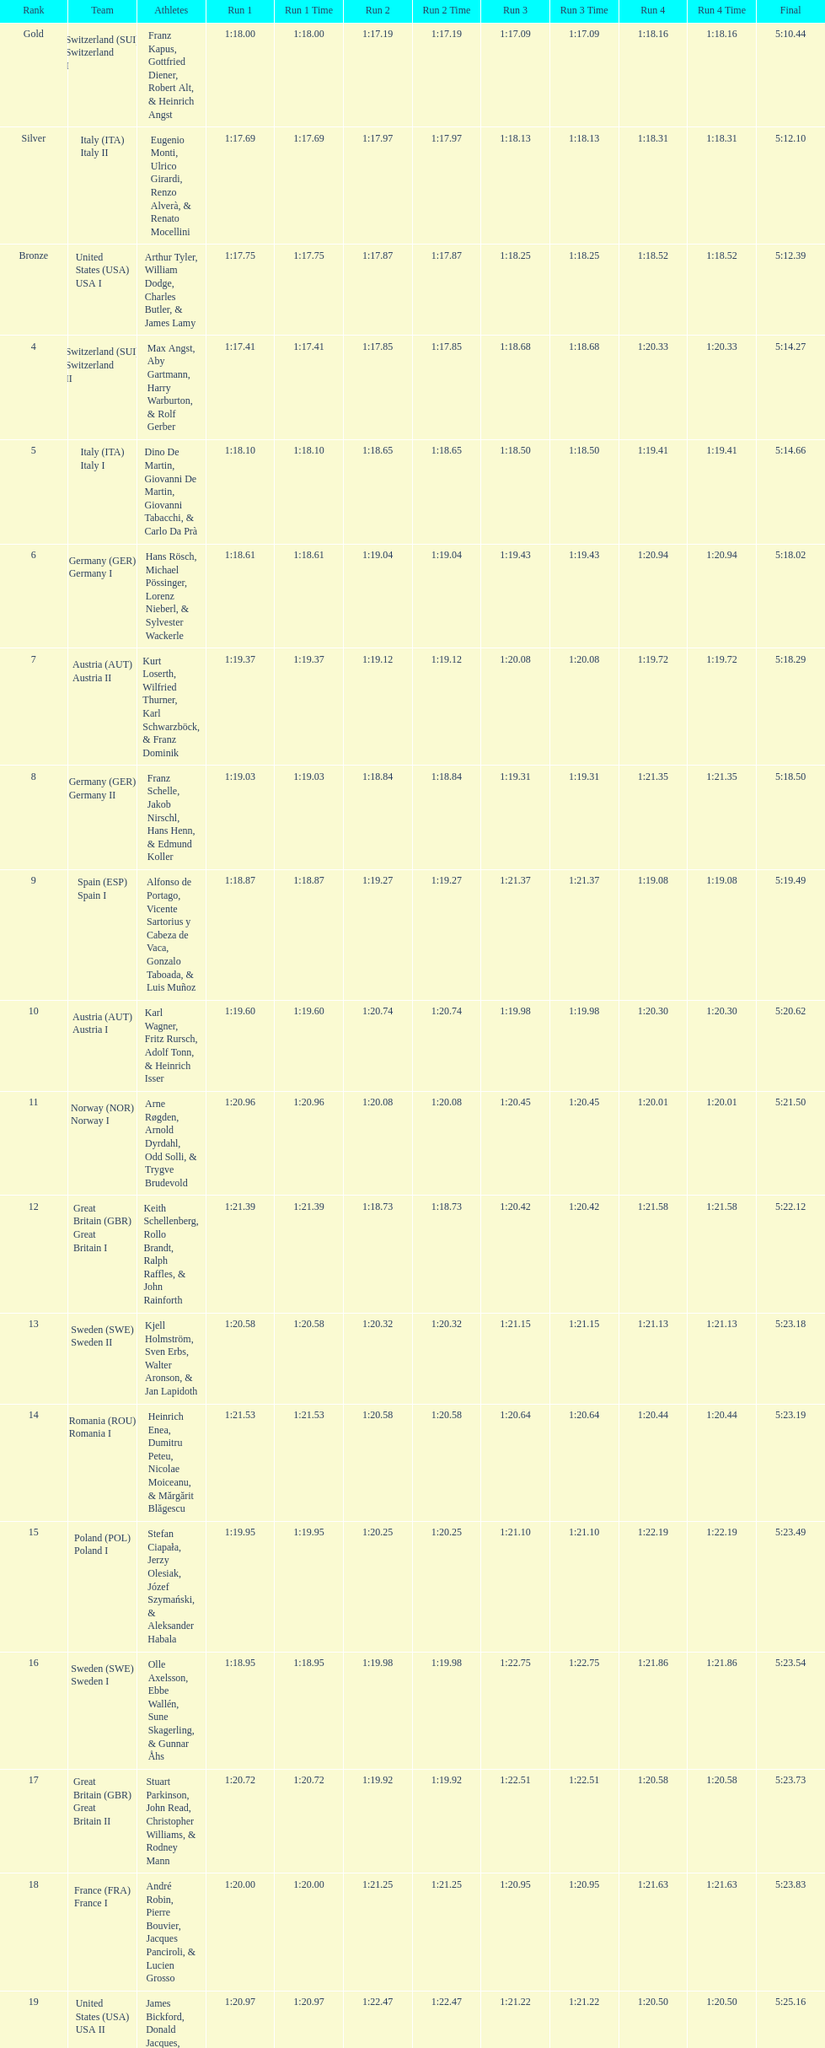Which team won the most runs? Switzerland. Would you be able to parse every entry in this table? {'header': ['Rank', 'Team', 'Athletes', 'Run 1', 'Run 1 Time', 'Run 2', 'Run 2 Time', 'Run 3', 'Run 3 Time', 'Run 4', 'Run 4 Time', 'Final'], 'rows': [['Gold', 'Switzerland\xa0(SUI) Switzerland I', 'Franz Kapus, Gottfried Diener, Robert Alt, & Heinrich Angst', '1:18.00', '1:18.00', '1:17.19', '1:17.19', '1:17.09', '1:17.09', '1:18.16', '1:18.16', '5:10.44'], ['Silver', 'Italy\xa0(ITA) Italy II', 'Eugenio Monti, Ulrico Girardi, Renzo Alverà, & Renato Mocellini', '1:17.69', '1:17.69', '1:17.97', '1:17.97', '1:18.13', '1:18.13', '1:18.31', '1:18.31', '5:12.10'], ['Bronze', 'United States\xa0(USA) USA I', 'Arthur Tyler, William Dodge, Charles Butler, & James Lamy', '1:17.75', '1:17.75', '1:17.87', '1:17.87', '1:18.25', '1:18.25', '1:18.52', '1:18.52', '5:12.39'], ['4', 'Switzerland\xa0(SUI) Switzerland II', 'Max Angst, Aby Gartmann, Harry Warburton, & Rolf Gerber', '1:17.41', '1:17.41', '1:17.85', '1:17.85', '1:18.68', '1:18.68', '1:20.33', '1:20.33', '5:14.27'], ['5', 'Italy\xa0(ITA) Italy I', 'Dino De Martin, Giovanni De Martin, Giovanni Tabacchi, & Carlo Da Prà', '1:18.10', '1:18.10', '1:18.65', '1:18.65', '1:18.50', '1:18.50', '1:19.41', '1:19.41', '5:14.66'], ['6', 'Germany\xa0(GER) Germany I', 'Hans Rösch, Michael Pössinger, Lorenz Nieberl, & Sylvester Wackerle', '1:18.61', '1:18.61', '1:19.04', '1:19.04', '1:19.43', '1:19.43', '1:20.94', '1:20.94', '5:18.02'], ['7', 'Austria\xa0(AUT) Austria II', 'Kurt Loserth, Wilfried Thurner, Karl Schwarzböck, & Franz Dominik', '1:19.37', '1:19.37', '1:19.12', '1:19.12', '1:20.08', '1:20.08', '1:19.72', '1:19.72', '5:18.29'], ['8', 'Germany\xa0(GER) Germany II', 'Franz Schelle, Jakob Nirschl, Hans Henn, & Edmund Koller', '1:19.03', '1:19.03', '1:18.84', '1:18.84', '1:19.31', '1:19.31', '1:21.35', '1:21.35', '5:18.50'], ['9', 'Spain\xa0(ESP) Spain I', 'Alfonso de Portago, Vicente Sartorius y Cabeza de Vaca, Gonzalo Taboada, & Luis Muñoz', '1:18.87', '1:18.87', '1:19.27', '1:19.27', '1:21.37', '1:21.37', '1:19.08', '1:19.08', '5:19.49'], ['10', 'Austria\xa0(AUT) Austria I', 'Karl Wagner, Fritz Rursch, Adolf Tonn, & Heinrich Isser', '1:19.60', '1:19.60', '1:20.74', '1:20.74', '1:19.98', '1:19.98', '1:20.30', '1:20.30', '5:20.62'], ['11', 'Norway\xa0(NOR) Norway I', 'Arne Røgden, Arnold Dyrdahl, Odd Solli, & Trygve Brudevold', '1:20.96', '1:20.96', '1:20.08', '1:20.08', '1:20.45', '1:20.45', '1:20.01', '1:20.01', '5:21.50'], ['12', 'Great Britain\xa0(GBR) Great Britain I', 'Keith Schellenberg, Rollo Brandt, Ralph Raffles, & John Rainforth', '1:21.39', '1:21.39', '1:18.73', '1:18.73', '1:20.42', '1:20.42', '1:21.58', '1:21.58', '5:22.12'], ['13', 'Sweden\xa0(SWE) Sweden II', 'Kjell Holmström, Sven Erbs, Walter Aronson, & Jan Lapidoth', '1:20.58', '1:20.58', '1:20.32', '1:20.32', '1:21.15', '1:21.15', '1:21.13', '1:21.13', '5:23.18'], ['14', 'Romania\xa0(ROU) Romania I', 'Heinrich Enea, Dumitru Peteu, Nicolae Moiceanu, & Mărgărit Blăgescu', '1:21.53', '1:21.53', '1:20.58', '1:20.58', '1:20.64', '1:20.64', '1:20.44', '1:20.44', '5:23.19'], ['15', 'Poland\xa0(POL) Poland I', 'Stefan Ciapała, Jerzy Olesiak, Józef Szymański, & Aleksander Habala', '1:19.95', '1:19.95', '1:20.25', '1:20.25', '1:21.10', '1:21.10', '1:22.19', '1:22.19', '5:23.49'], ['16', 'Sweden\xa0(SWE) Sweden I', 'Olle Axelsson, Ebbe Wallén, Sune Skagerling, & Gunnar Åhs', '1:18.95', '1:18.95', '1:19.98', '1:19.98', '1:22.75', '1:22.75', '1:21.86', '1:21.86', '5:23.54'], ['17', 'Great Britain\xa0(GBR) Great Britain II', 'Stuart Parkinson, John Read, Christopher Williams, & Rodney Mann', '1:20.72', '1:20.72', '1:19.92', '1:19.92', '1:22.51', '1:22.51', '1:20.58', '1:20.58', '5:23.73'], ['18', 'France\xa0(FRA) France I', 'André Robin, Pierre Bouvier, Jacques Panciroli, & Lucien Grosso', '1:20.00', '1:20.00', '1:21.25', '1:21.25', '1:20.95', '1:20.95', '1:21.63', '1:21.63', '5:23.83'], ['19', 'United States\xa0(USA) USA II', 'James Bickford, Donald Jacques, Lawrence McKillip, & Hubert Miller', '1:20.97', '1:20.97', '1:22.47', '1:22.47', '1:21.22', '1:21.22', '1:20.50', '1:20.50', '5:25.16'], ['20', 'Romania\xa0(ROU) Romania II', 'Constantin Dragomir, Vasile Panait, Ion Staicu, & Gheorghe Moldoveanu', '1:21.21', '1:21.21', '1:21.22', '1:21.22', '1:22.37', '1:22.37', '1:23.03', '1:23.03', '5:27.83'], ['21', 'Poland\xa0(POL) Poland II', 'Aleksy Konieczny, Zygmunt Konieczny, Włodzimierz Źróbik, & Zbigniew Skowroński/Jan Dąbrowski(*)', '', '-', '', '-', '', '-', '', '-', '5:28.40']]} 